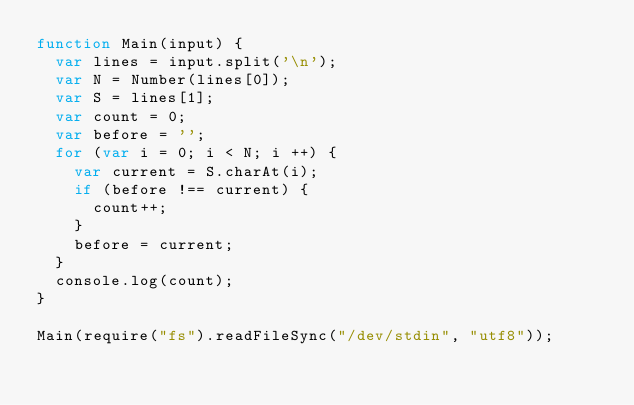<code> <loc_0><loc_0><loc_500><loc_500><_JavaScript_>function Main(input) {
  var lines = input.split('\n');
  var N = Number(lines[0]);
  var S = lines[1];
  var count = 0;
  var before = '';
  for (var i = 0; i < N; i ++) {
    var current = S.charAt(i);
    if (before !== current) {
      count++;
    }
    before = current;
  }
  console.log(count);
}

Main(require("fs").readFileSync("/dev/stdin", "utf8"));
</code> 